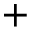<formula> <loc_0><loc_0><loc_500><loc_500>+</formula> 